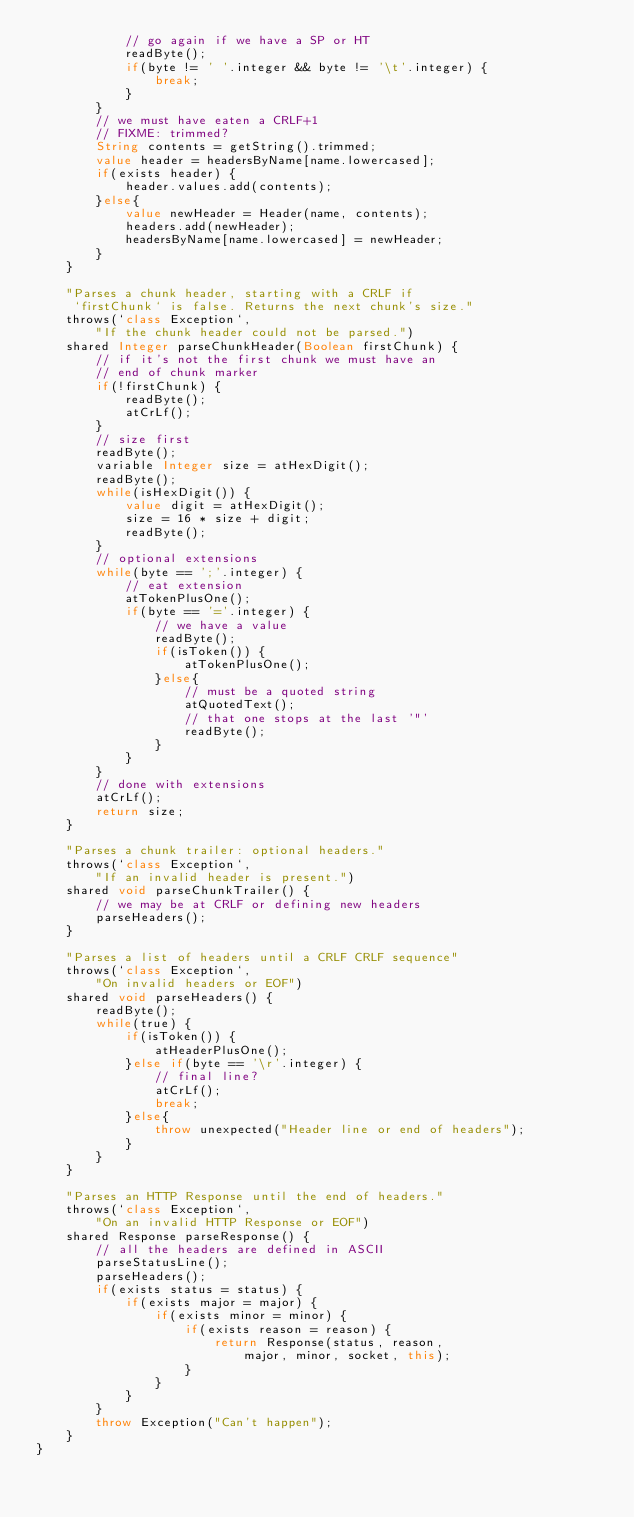<code> <loc_0><loc_0><loc_500><loc_500><_Ceylon_>            // go again if we have a SP or HT
            readByte();
            if(byte != ' '.integer && byte != '\t'.integer) {
                break;
            }
        }
        // we must have eaten a CRLF+1
        // FIXME: trimmed?
        String contents = getString().trimmed;
        value header = headersByName[name.lowercased];
        if(exists header) {
            header.values.add(contents);
        }else{
            value newHeader = Header(name, contents);
            headers.add(newHeader);
            headersByName[name.lowercased] = newHeader;
        }
    }
    
    "Parses a chunk header, starting with a CRLF if 
     `firstChunk` is false. Returns the next chunk's size."
    throws(`class Exception`, 
        "If the chunk header could not be parsed.")
    shared Integer parseChunkHeader(Boolean firstChunk) {
        // if it's not the first chunk we must have an 
        // end of chunk marker
        if(!firstChunk) {
            readByte();
            atCrLf();
        }
        // size first
        readByte();
        variable Integer size = atHexDigit();
        readByte();
        while(isHexDigit()) {
            value digit = atHexDigit();
            size = 16 * size + digit;
            readByte();
        }
        // optional extensions
        while(byte == ';'.integer) {
            // eat extension
            atTokenPlusOne();
            if(byte == '='.integer) {
                // we have a value
                readByte();
                if(isToken()) {
                    atTokenPlusOne();
                }else{
                    // must be a quoted string
                    atQuotedText();
                    // that one stops at the last '"'
                    readByte();
                }
            }
        }
        // done with extensions
        atCrLf();
        return size;
    }
    
    "Parses a chunk trailer: optional headers."
    throws(`class Exception`, 
        "If an invalid header is present.")
    shared void parseChunkTrailer() {
        // we may be at CRLF or defining new headers
        parseHeaders();
    }
    
    "Parses a list of headers until a CRLF CRLF sequence"
    throws(`class Exception`, 
        "On invalid headers or EOF")
    shared void parseHeaders() {
        readByte();
        while(true) {
            if(isToken()) {
                atHeaderPlusOne();
            }else if(byte == '\r'.integer) {
                // final line?
                atCrLf();
                break;
            }else{
                throw unexpected("Header line or end of headers");
            }
        }
    }
    
    "Parses an HTTP Response until the end of headers."
    throws(`class Exception`, 
        "On an invalid HTTP Response or EOF")
    shared Response parseResponse() {
        // all the headers are defined in ASCII
        parseStatusLine();
        parseHeaders();
        if(exists status = status) {
            if(exists major = major) {
                if(exists minor = minor) {
                    if(exists reason = reason) {
                        return Response(status, reason, 
                            major, minor, socket, this);
                    }
                }
            }
        }
        throw Exception("Can't happen");
    }
}
</code> 